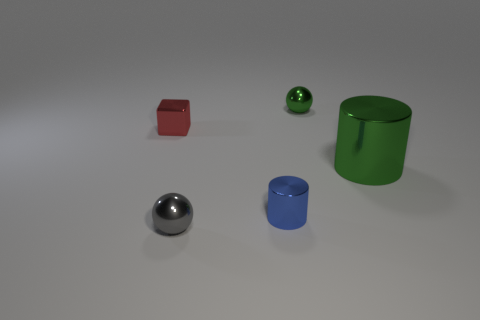Can you tell me about the lighting in the scene? The scene is illuminated by a broad light source, creating soft shadows under each object, indicating a diffused lighting setup that resembles natural daylight in an indoor setting. 